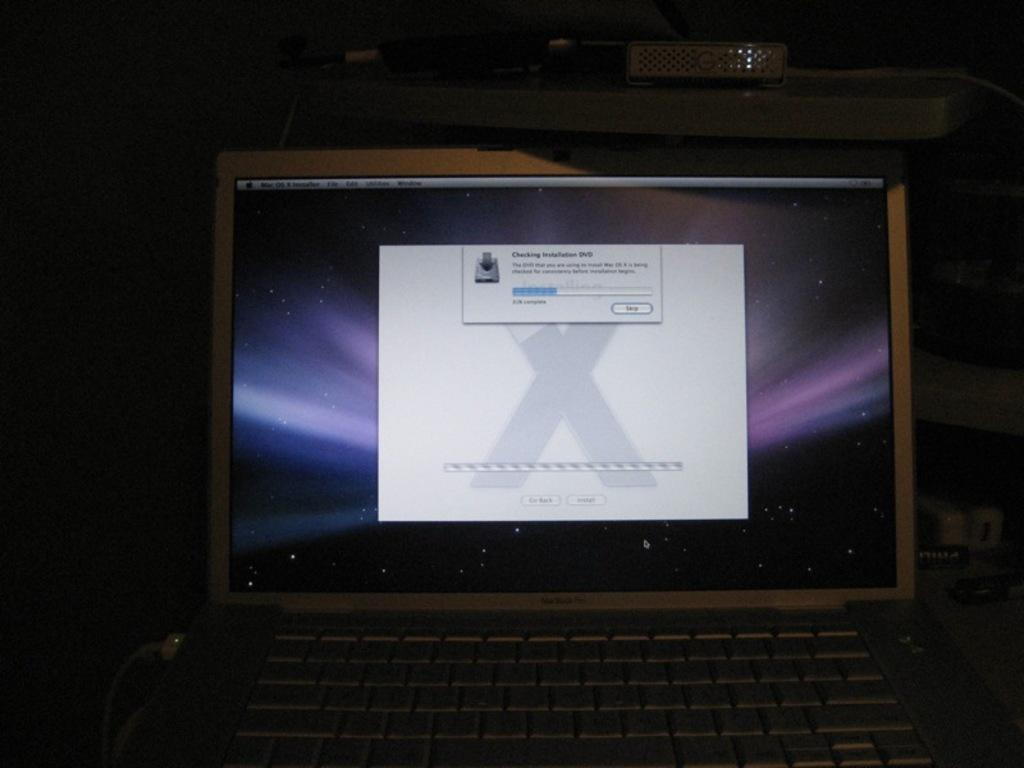<image>
Provide a brief description of the given image. A computer monitor has a window open that is checking for installation cd. 